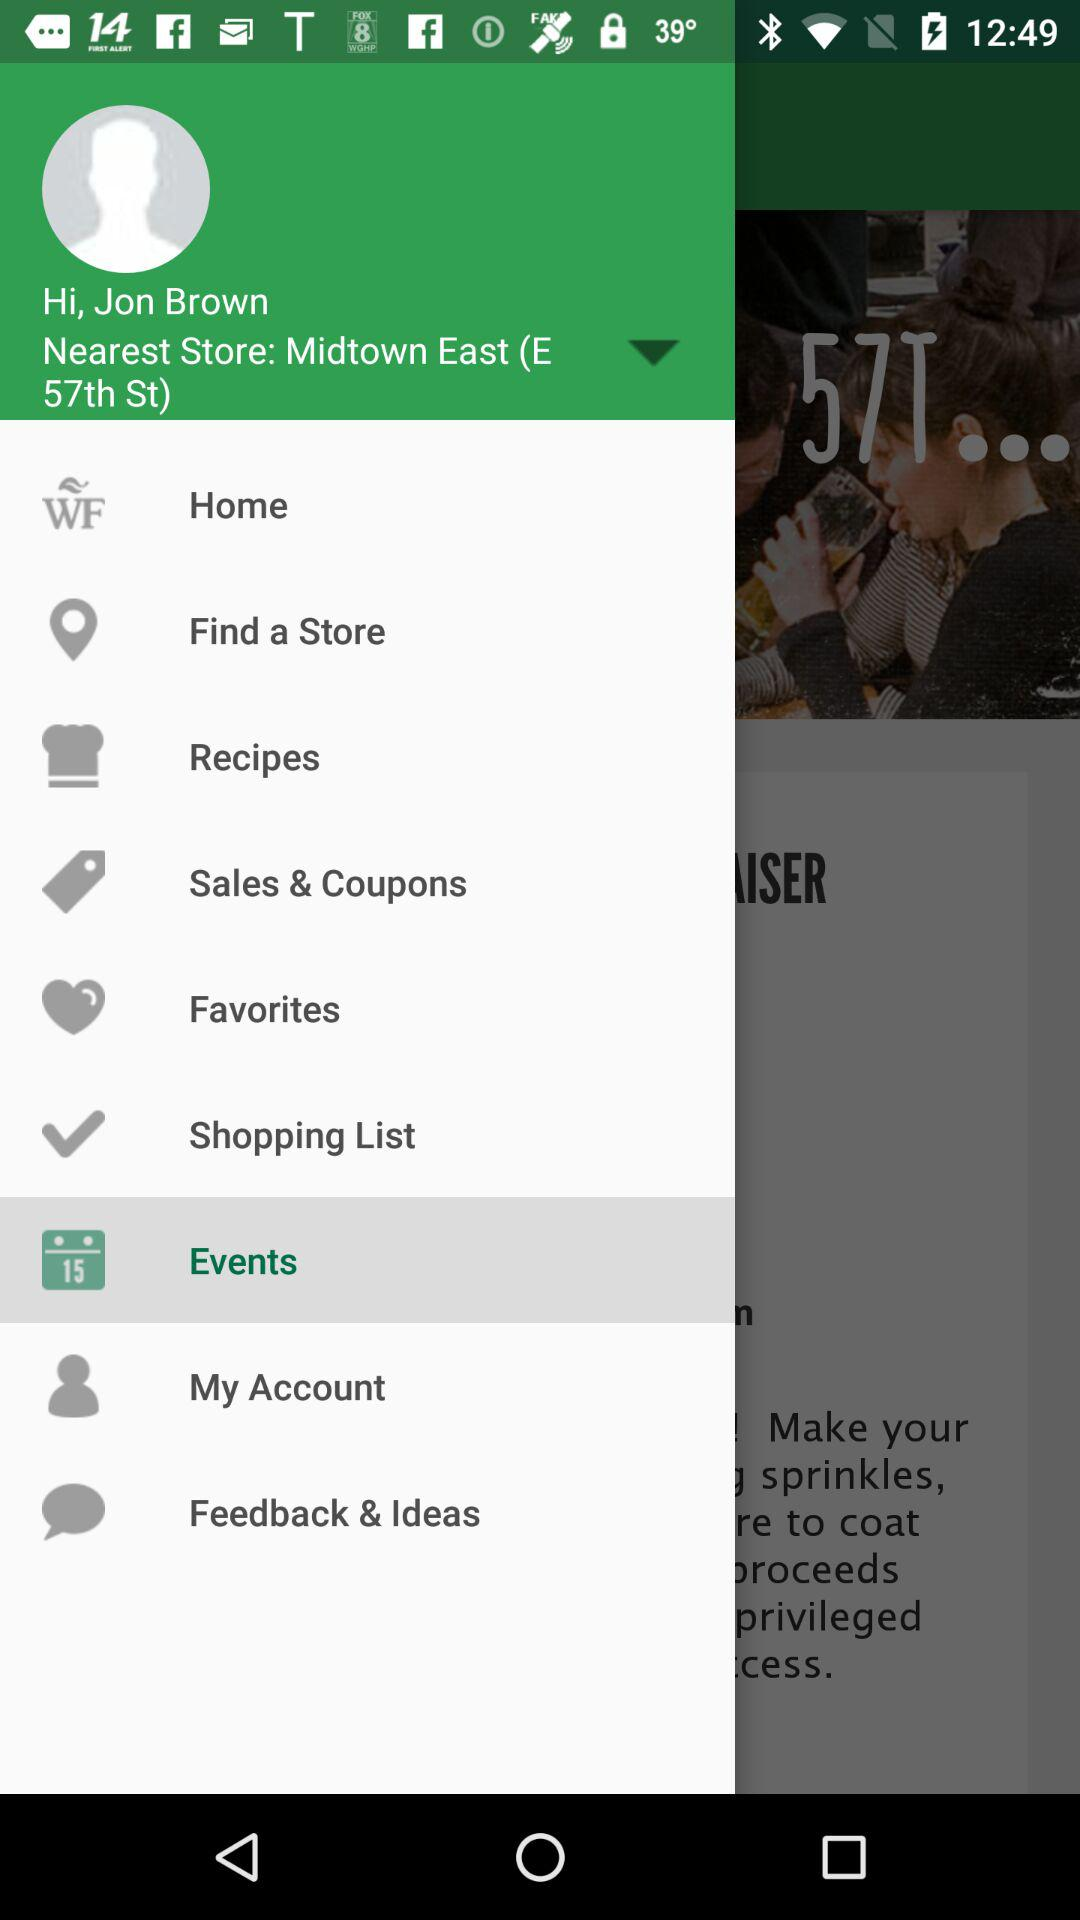What's the nearest store address? The nearest store address is Midtown East (E 57th St.). 